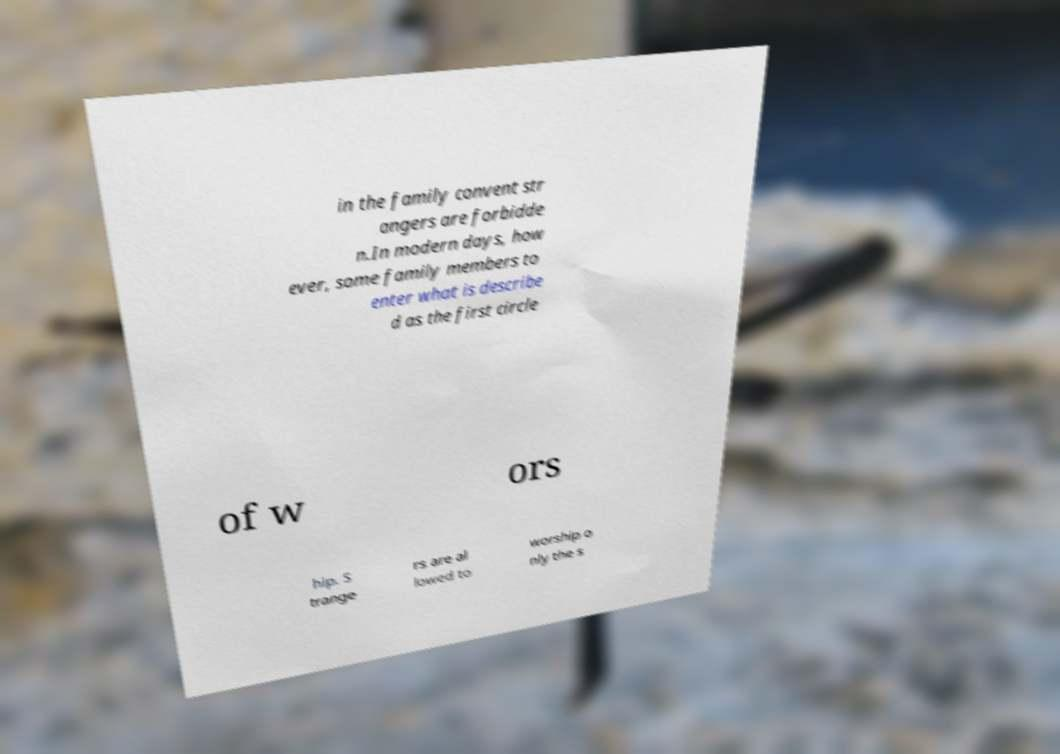For documentation purposes, I need the text within this image transcribed. Could you provide that? in the family convent str angers are forbidde n.In modern days, how ever, some family members to enter what is describe d as the first circle of w ors hip. S trange rs are al lowed to worship o nly the s 